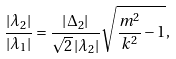<formula> <loc_0><loc_0><loc_500><loc_500>\frac { { \left | { \lambda _ { 2 } } \right | } } { { \left | { \lambda _ { 1 } } \right | } } = \frac { { \left | { \Delta _ { 2 } } \right | } } { { \sqrt { 2 } \left | { \lambda _ { 2 } } \right | } } \sqrt { \frac { m ^ { 2 } } { k ^ { 2 } } - 1 } ,</formula> 